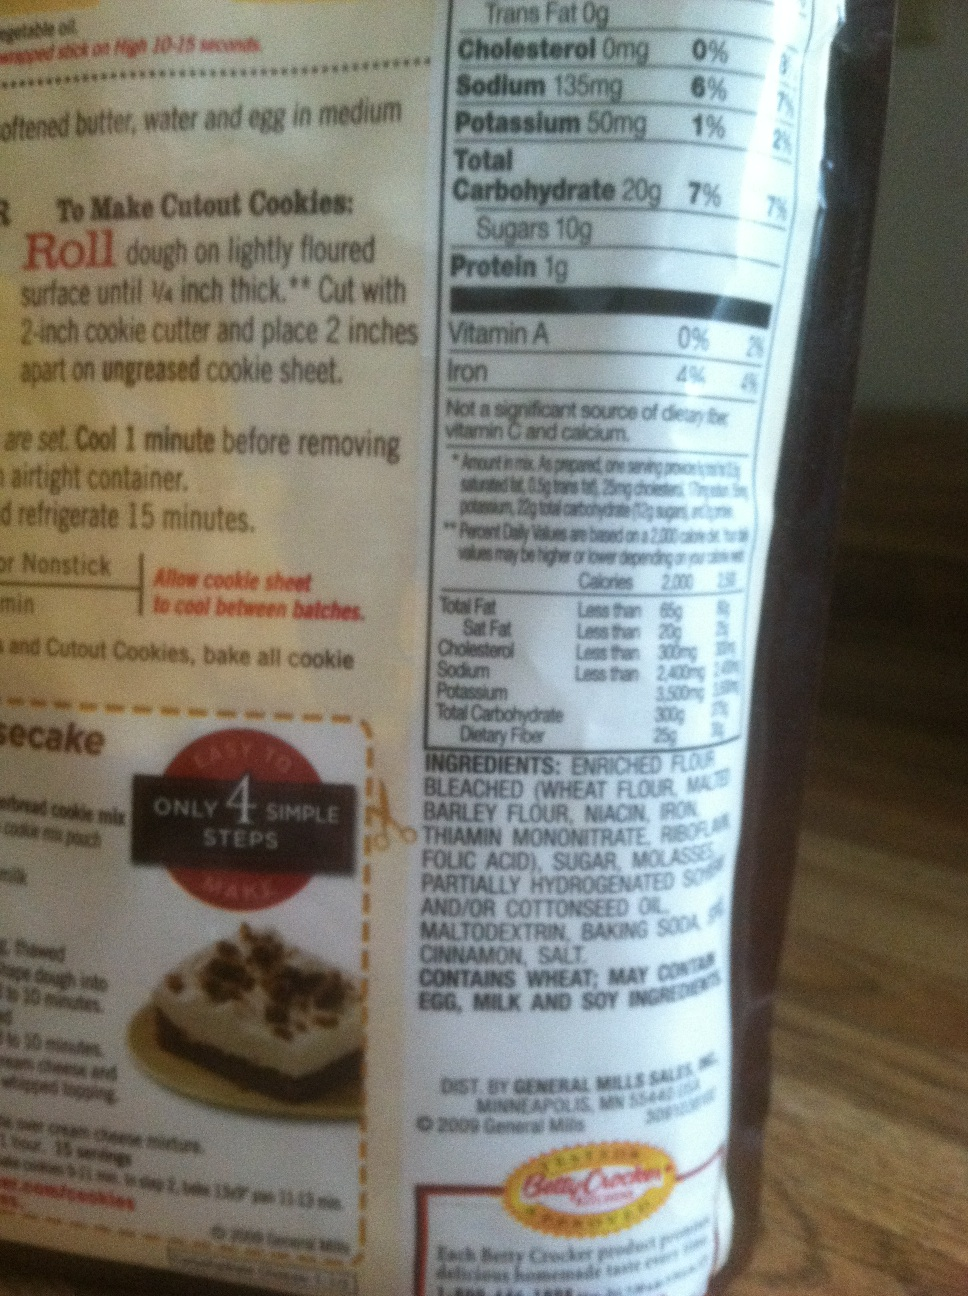What recipe instructions are provided on this bag? The instructions for making cutout cookies are: roll the dough on a lightly floured surface until it is 1/4 inch thick. Then, use a 2-inch cookie cutter to cut out shapes and place them 2 inches apart on an ungreased cookie sheet. Bake according to the directions, then cool for 1 minute before transferring to an airtight container. 